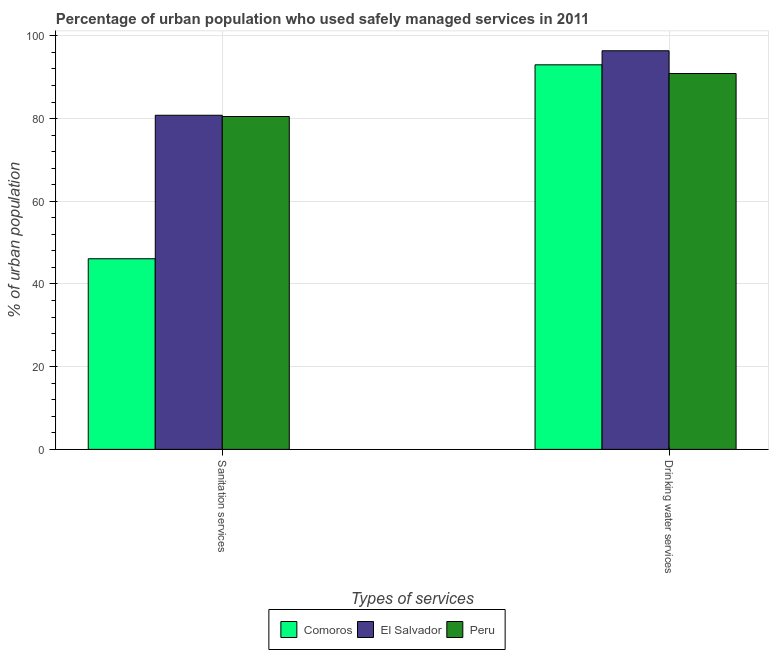How many different coloured bars are there?
Offer a terse response. 3. How many groups of bars are there?
Offer a very short reply. 2. Are the number of bars per tick equal to the number of legend labels?
Keep it short and to the point. Yes. Are the number of bars on each tick of the X-axis equal?
Keep it short and to the point. Yes. What is the label of the 1st group of bars from the left?
Your response must be concise. Sanitation services. What is the percentage of urban population who used sanitation services in El Salvador?
Give a very brief answer. 80.8. Across all countries, what is the maximum percentage of urban population who used sanitation services?
Offer a very short reply. 80.8. Across all countries, what is the minimum percentage of urban population who used sanitation services?
Make the answer very short. 46.1. In which country was the percentage of urban population who used sanitation services maximum?
Give a very brief answer. El Salvador. In which country was the percentage of urban population who used sanitation services minimum?
Make the answer very short. Comoros. What is the total percentage of urban population who used drinking water services in the graph?
Offer a terse response. 280.3. What is the difference between the percentage of urban population who used sanitation services in Comoros and that in Peru?
Offer a terse response. -34.4. What is the difference between the percentage of urban population who used drinking water services in El Salvador and the percentage of urban population who used sanitation services in Peru?
Make the answer very short. 15.9. What is the average percentage of urban population who used sanitation services per country?
Make the answer very short. 69.13. What is the difference between the percentage of urban population who used drinking water services and percentage of urban population who used sanitation services in Comoros?
Offer a very short reply. 46.9. What is the ratio of the percentage of urban population who used sanitation services in Peru to that in Comoros?
Your response must be concise. 1.75. What does the 2nd bar from the left in Sanitation services represents?
Provide a short and direct response. El Salvador. What does the 3rd bar from the right in Sanitation services represents?
Make the answer very short. Comoros. How many bars are there?
Your answer should be compact. 6. Does the graph contain any zero values?
Provide a succinct answer. No. How many legend labels are there?
Provide a short and direct response. 3. What is the title of the graph?
Ensure brevity in your answer.  Percentage of urban population who used safely managed services in 2011. Does "Bangladesh" appear as one of the legend labels in the graph?
Offer a terse response. No. What is the label or title of the X-axis?
Your answer should be compact. Types of services. What is the label or title of the Y-axis?
Your answer should be very brief. % of urban population. What is the % of urban population of Comoros in Sanitation services?
Offer a terse response. 46.1. What is the % of urban population of El Salvador in Sanitation services?
Your answer should be compact. 80.8. What is the % of urban population of Peru in Sanitation services?
Your answer should be very brief. 80.5. What is the % of urban population of Comoros in Drinking water services?
Your answer should be very brief. 93. What is the % of urban population in El Salvador in Drinking water services?
Offer a very short reply. 96.4. What is the % of urban population in Peru in Drinking water services?
Your answer should be compact. 90.9. Across all Types of services, what is the maximum % of urban population of Comoros?
Offer a terse response. 93. Across all Types of services, what is the maximum % of urban population in El Salvador?
Offer a terse response. 96.4. Across all Types of services, what is the maximum % of urban population in Peru?
Offer a terse response. 90.9. Across all Types of services, what is the minimum % of urban population of Comoros?
Offer a terse response. 46.1. Across all Types of services, what is the minimum % of urban population of El Salvador?
Keep it short and to the point. 80.8. Across all Types of services, what is the minimum % of urban population in Peru?
Ensure brevity in your answer.  80.5. What is the total % of urban population of Comoros in the graph?
Provide a succinct answer. 139.1. What is the total % of urban population of El Salvador in the graph?
Give a very brief answer. 177.2. What is the total % of urban population in Peru in the graph?
Provide a succinct answer. 171.4. What is the difference between the % of urban population of Comoros in Sanitation services and that in Drinking water services?
Your answer should be very brief. -46.9. What is the difference between the % of urban population of El Salvador in Sanitation services and that in Drinking water services?
Provide a short and direct response. -15.6. What is the difference between the % of urban population in Comoros in Sanitation services and the % of urban population in El Salvador in Drinking water services?
Make the answer very short. -50.3. What is the difference between the % of urban population in Comoros in Sanitation services and the % of urban population in Peru in Drinking water services?
Your response must be concise. -44.8. What is the average % of urban population of Comoros per Types of services?
Ensure brevity in your answer.  69.55. What is the average % of urban population of El Salvador per Types of services?
Your answer should be compact. 88.6. What is the average % of urban population in Peru per Types of services?
Keep it short and to the point. 85.7. What is the difference between the % of urban population in Comoros and % of urban population in El Salvador in Sanitation services?
Make the answer very short. -34.7. What is the difference between the % of urban population in Comoros and % of urban population in Peru in Sanitation services?
Give a very brief answer. -34.4. What is the difference between the % of urban population of El Salvador and % of urban population of Peru in Drinking water services?
Offer a very short reply. 5.5. What is the ratio of the % of urban population of Comoros in Sanitation services to that in Drinking water services?
Provide a succinct answer. 0.5. What is the ratio of the % of urban population in El Salvador in Sanitation services to that in Drinking water services?
Keep it short and to the point. 0.84. What is the ratio of the % of urban population of Peru in Sanitation services to that in Drinking water services?
Provide a succinct answer. 0.89. What is the difference between the highest and the second highest % of urban population in Comoros?
Your answer should be compact. 46.9. What is the difference between the highest and the lowest % of urban population in Comoros?
Offer a terse response. 46.9. 